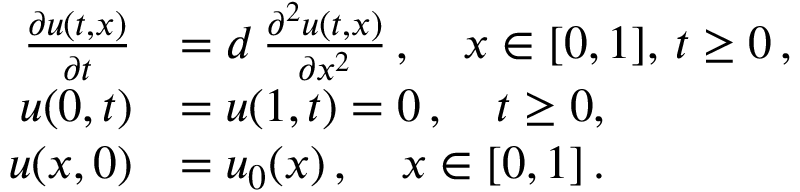<formula> <loc_0><loc_0><loc_500><loc_500>\begin{array} { r l } { \frac { \partial u ( t , x ) } { \partial t } } & { = d \, \frac { \partial ^ { 2 } u ( t , x ) } { \partial x ^ { 2 } } \, , \quad x \in [ 0 , 1 ] , \, t \geq 0 \, , } \\ { u ( 0 , t ) } & { = u ( 1 , t ) = 0 \, , \quad t \geq 0 , } \\ { u ( x , 0 ) } & { = u _ { 0 } ( x ) \, , \quad x \in [ 0 , 1 ] \, . } \end{array}</formula> 